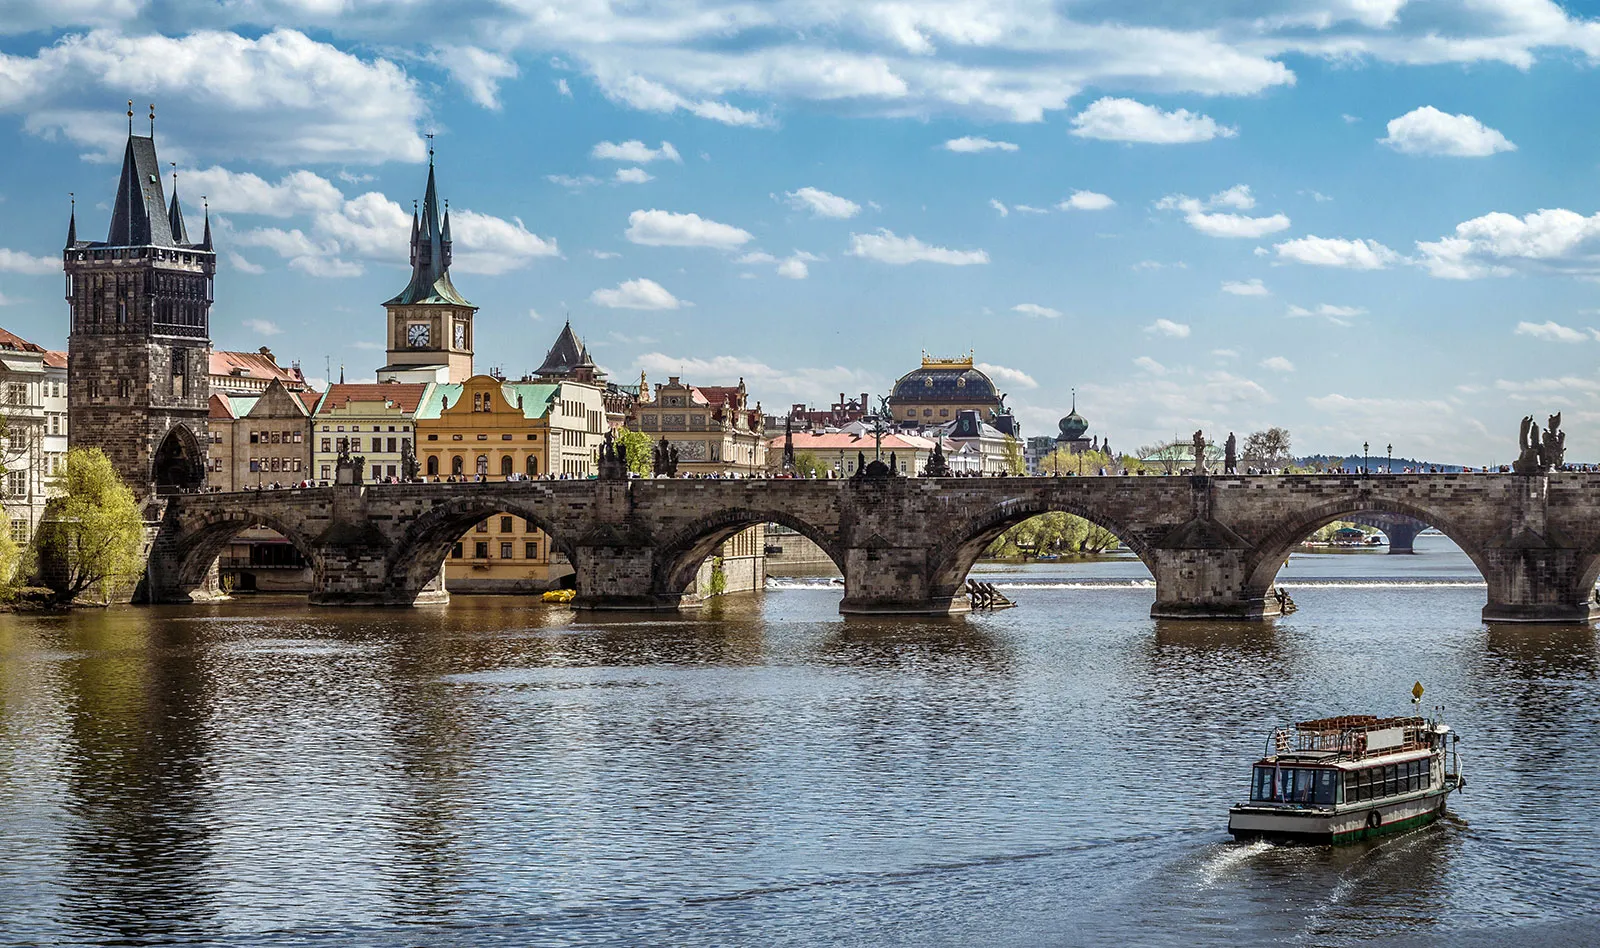Explain the visual content of the image in great detail. The image beautifully captures Prague's Charles Bridge under a clear sky. This historic stone bridge spans the tranquil Vltava River and is lined with intricately carved statues, each bearing significant historical and cultural value. The bridge's Gothic architecture, characterized by its robust towers at either end, stands out brilliantly against the blue backdrop of the sky, scattered with soft, white clouds. Below, the river reflects the city's serene environment as a traditional boat gently navigates its waters, hinting at the vibrant life that flows through this ancient city. 